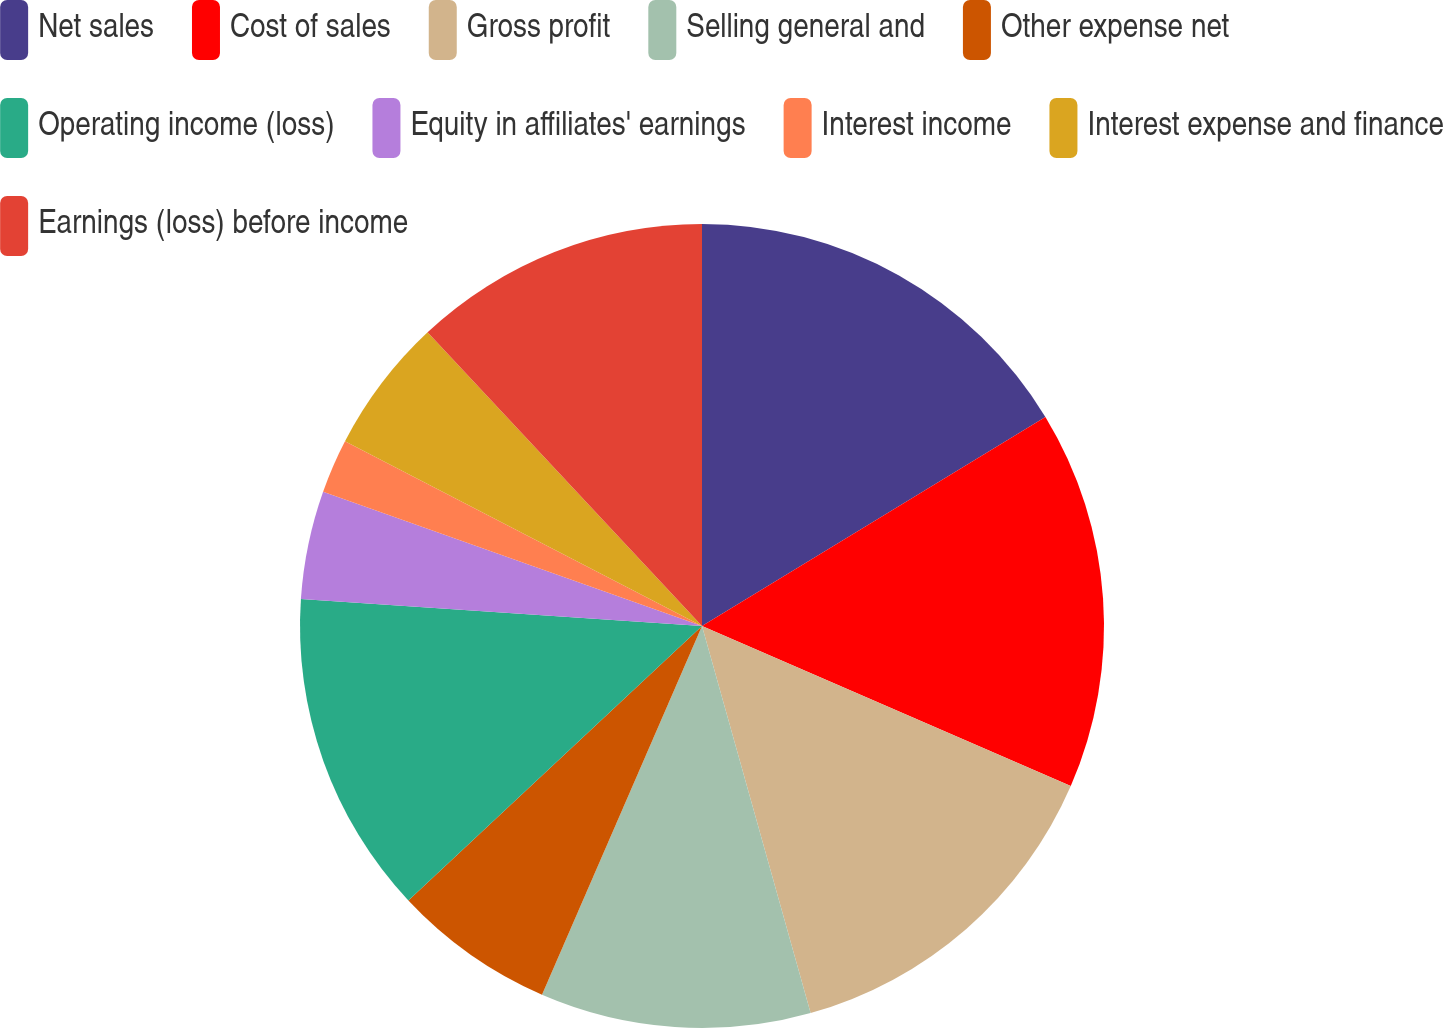<chart> <loc_0><loc_0><loc_500><loc_500><pie_chart><fcel>Net sales<fcel>Cost of sales<fcel>Gross profit<fcel>Selling general and<fcel>Other expense net<fcel>Operating income (loss)<fcel>Equity in affiliates' earnings<fcel>Interest income<fcel>Interest expense and finance<fcel>Earnings (loss) before income<nl><fcel>16.3%<fcel>15.22%<fcel>14.13%<fcel>10.87%<fcel>6.52%<fcel>13.04%<fcel>4.35%<fcel>2.18%<fcel>5.44%<fcel>11.96%<nl></chart> 